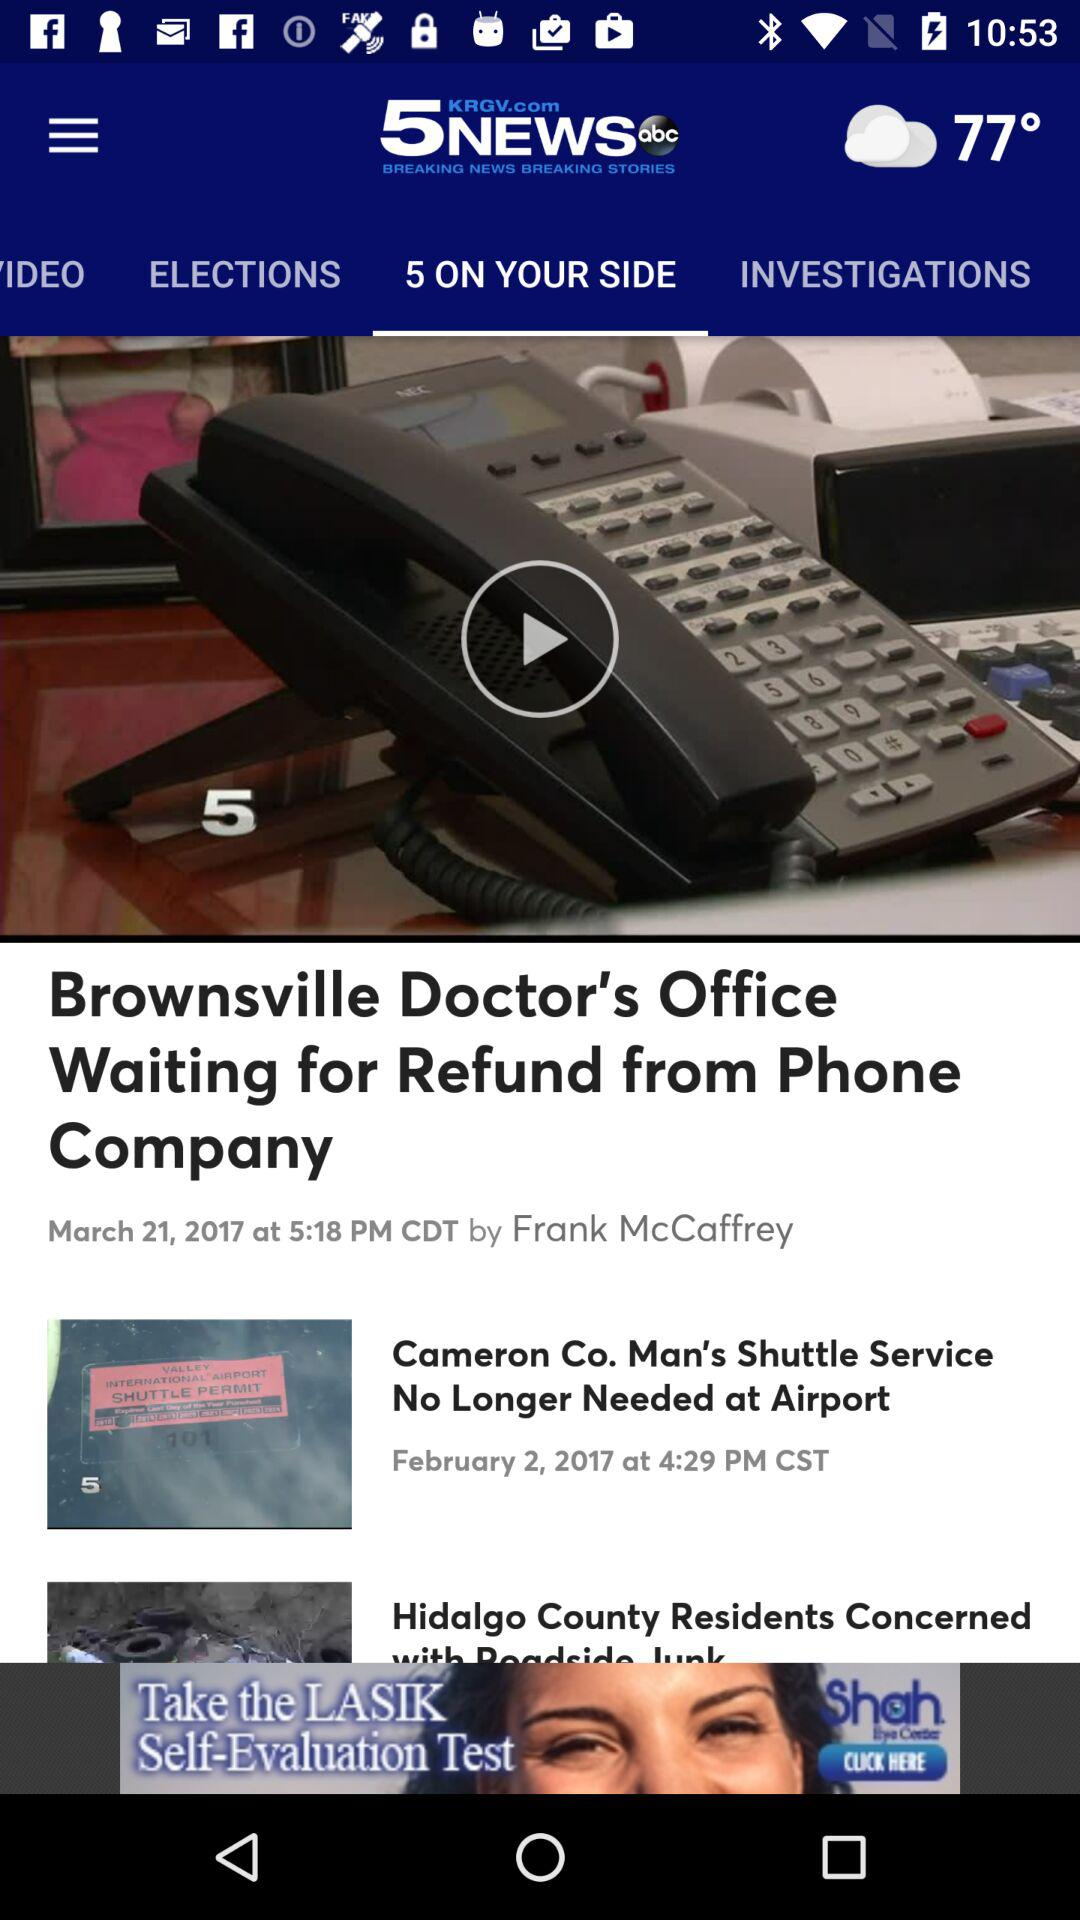Which tab is selected? The selected tab is "5 ON YOUR SIDE". 